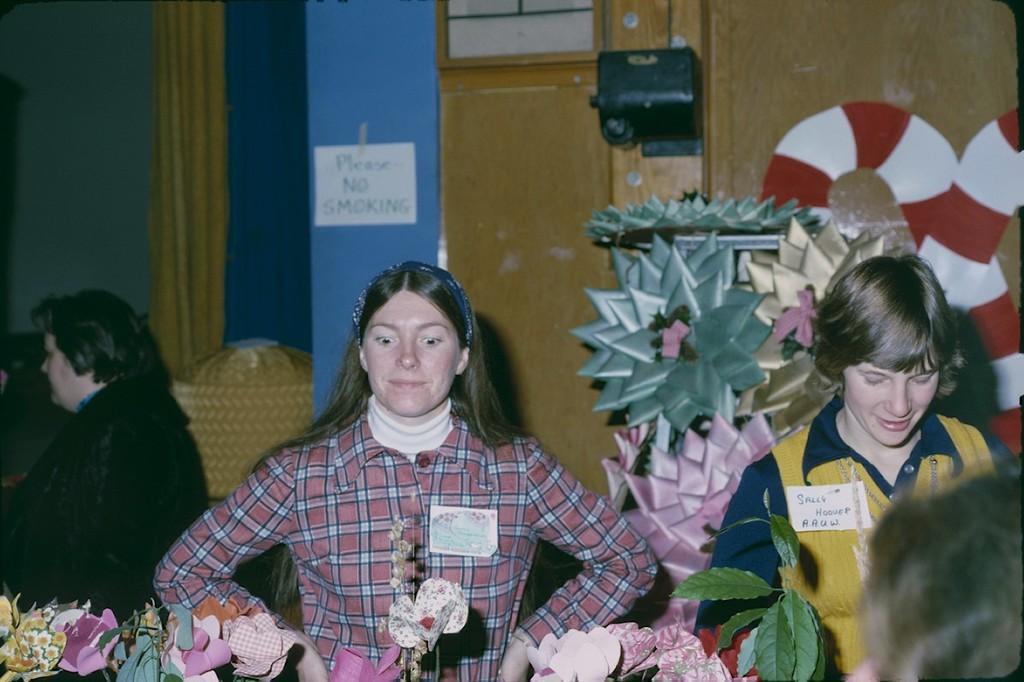Please provide a concise description of this image. In the picture we can see few women are standing and working and they are holding a batch of their shirts and in the background, we can see a wall with some curtain, and pillar with some note to it. 